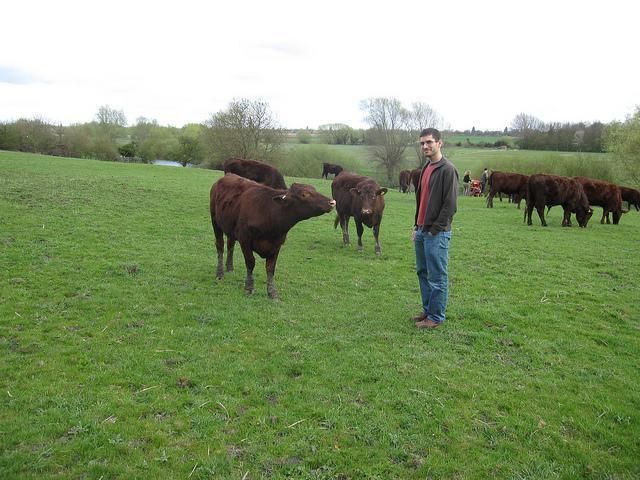How many white feet?
Give a very brief answer. 0. How many people are there?
Give a very brief answer. 1. How many cows can you see?
Give a very brief answer. 3. How many surfboards are behind the man?
Give a very brief answer. 0. 